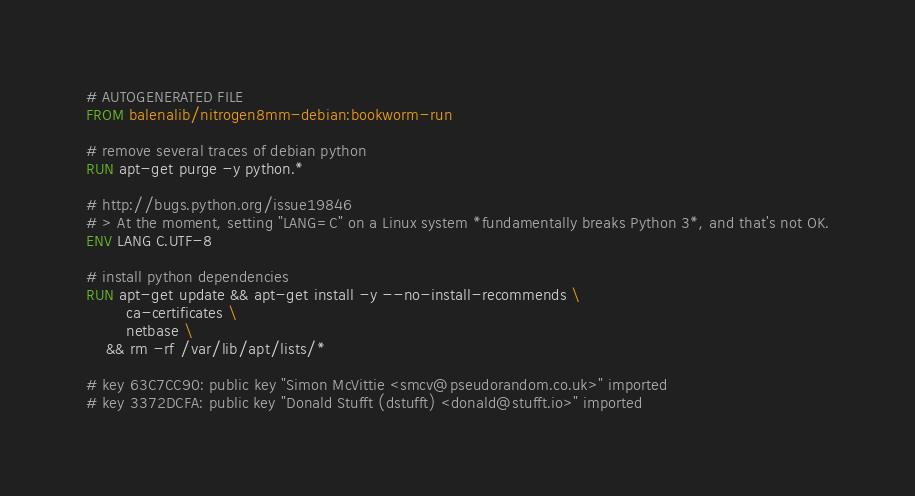Convert code to text. <code><loc_0><loc_0><loc_500><loc_500><_Dockerfile_># AUTOGENERATED FILE
FROM balenalib/nitrogen8mm-debian:bookworm-run

# remove several traces of debian python
RUN apt-get purge -y python.*

# http://bugs.python.org/issue19846
# > At the moment, setting "LANG=C" on a Linux system *fundamentally breaks Python 3*, and that's not OK.
ENV LANG C.UTF-8

# install python dependencies
RUN apt-get update && apt-get install -y --no-install-recommends \
		ca-certificates \
		netbase \
	&& rm -rf /var/lib/apt/lists/*

# key 63C7CC90: public key "Simon McVittie <smcv@pseudorandom.co.uk>" imported
# key 3372DCFA: public key "Donald Stufft (dstufft) <donald@stufft.io>" imported</code> 